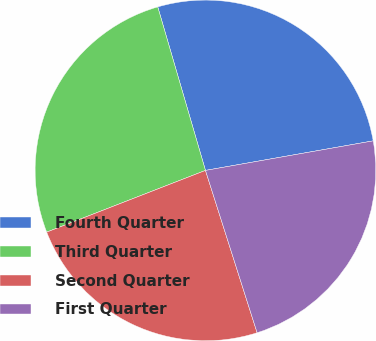Convert chart to OTSL. <chart><loc_0><loc_0><loc_500><loc_500><pie_chart><fcel>Fourth Quarter<fcel>Third Quarter<fcel>Second Quarter<fcel>First Quarter<nl><fcel>26.74%<fcel>26.38%<fcel>24.0%<fcel>22.87%<nl></chart> 